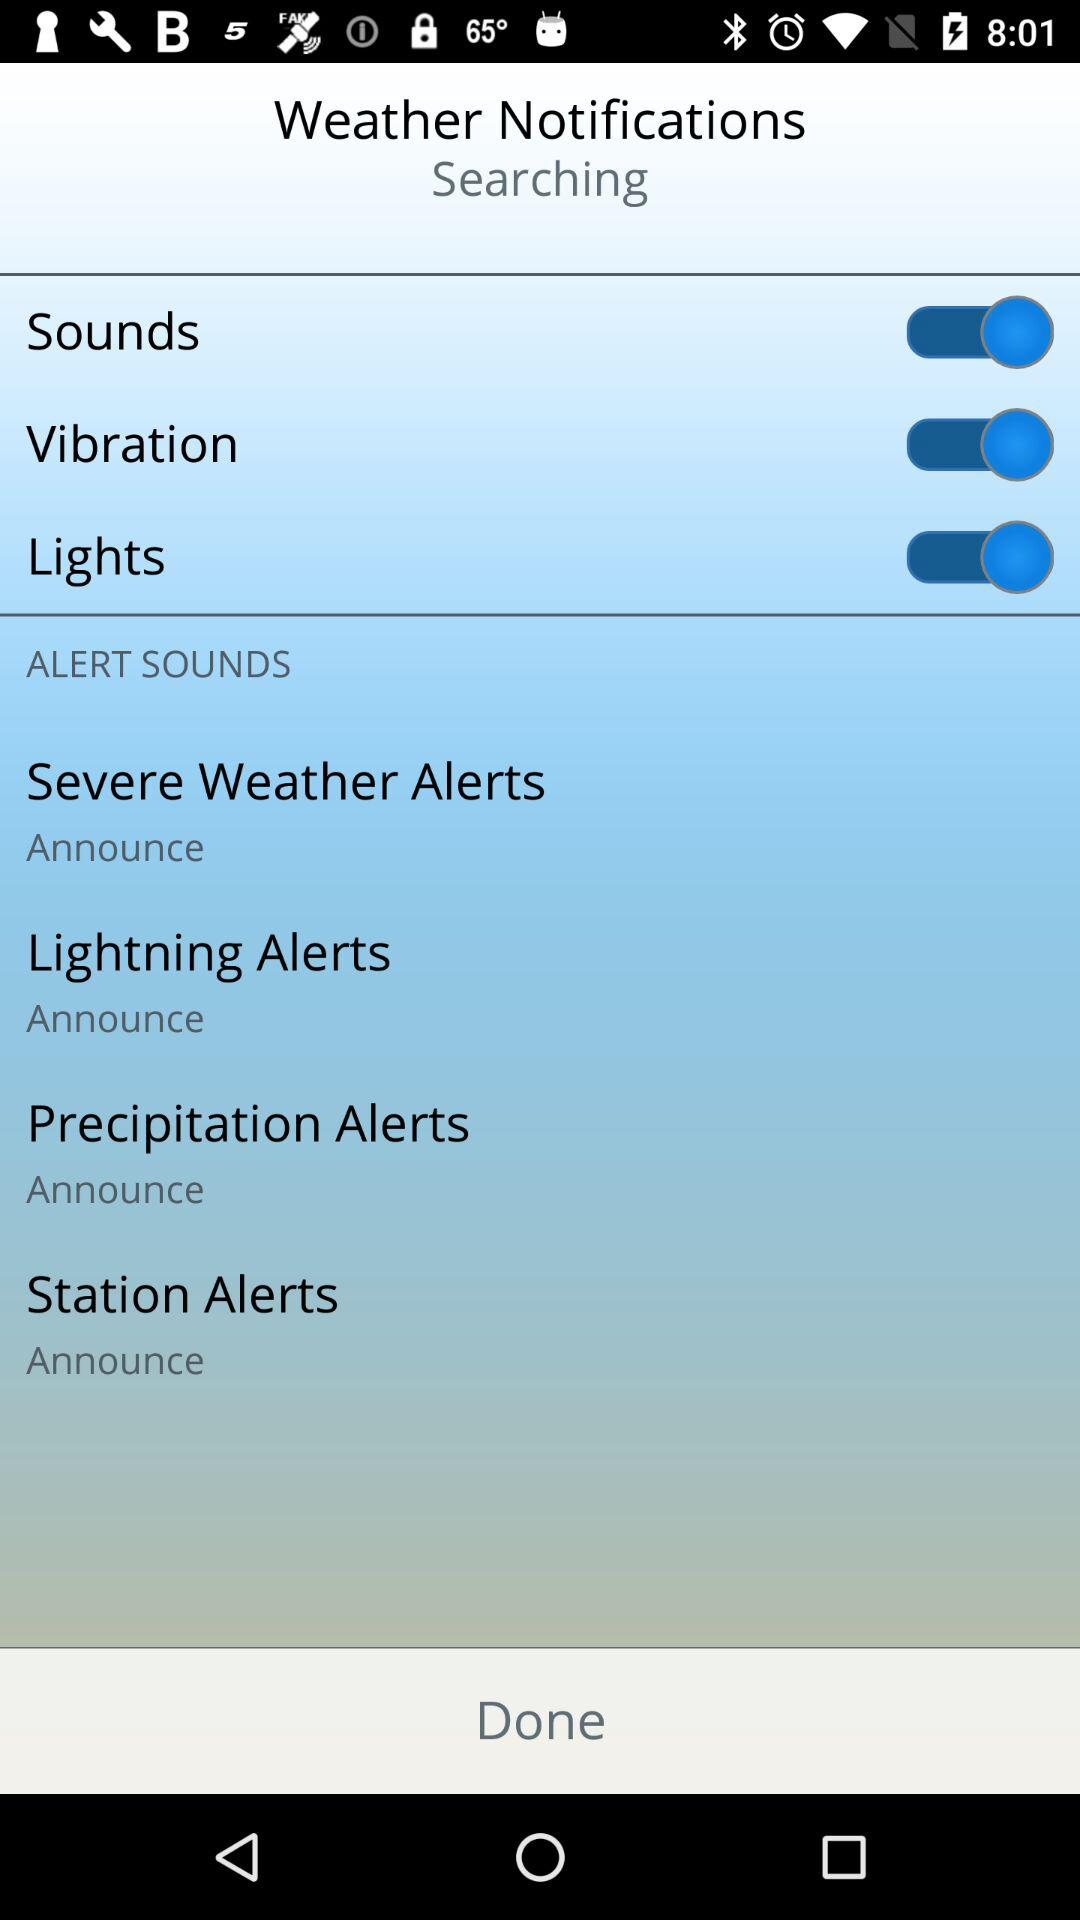How many more alert sounds are there than vibration or light alerts?
Answer the question using a single word or phrase. 2 